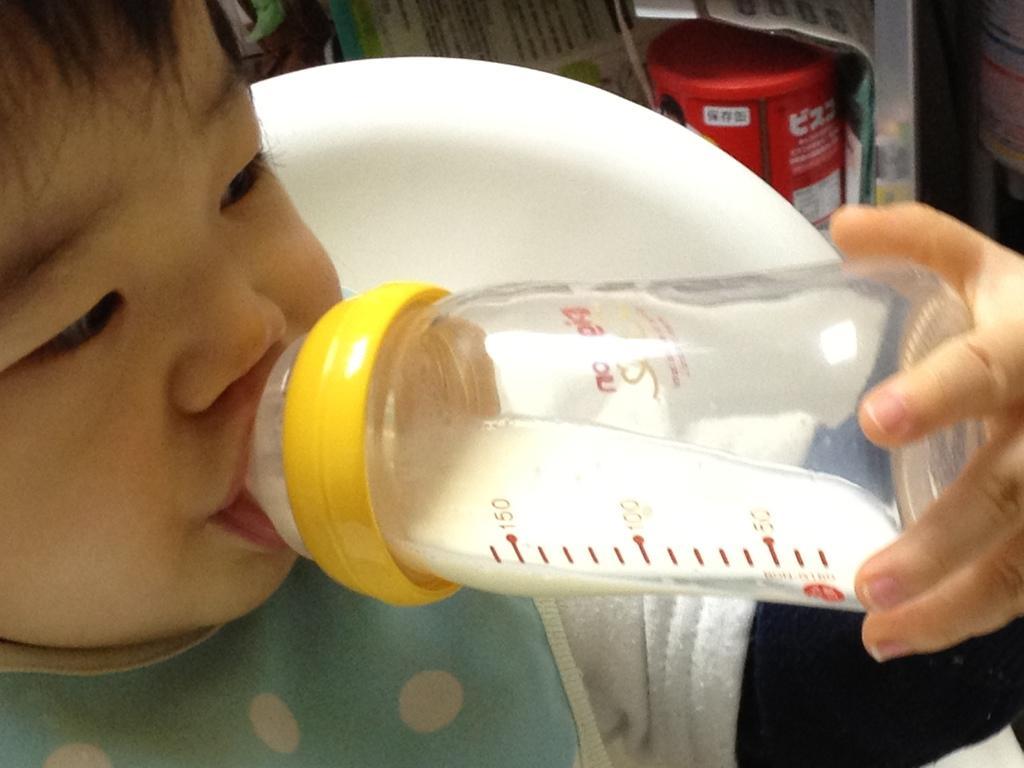Please provide a concise description of this image. In this picture there is a baby drinking the milk in the bottle and the background there is a chair , box and another person. 